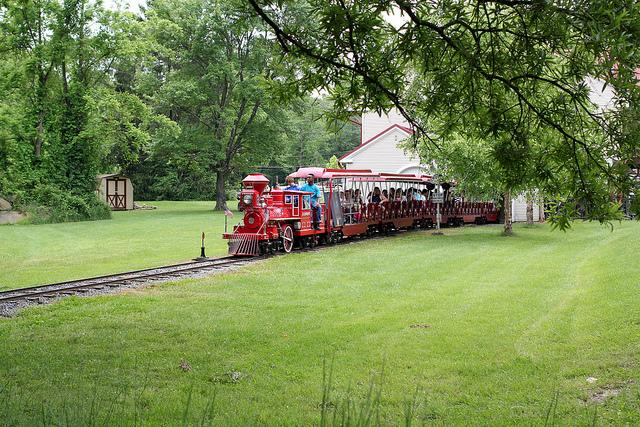What is the small brown structure in the back left of the yard?

Choices:
A) shed
B) outhouse
C) phonebooth
D) church shed 